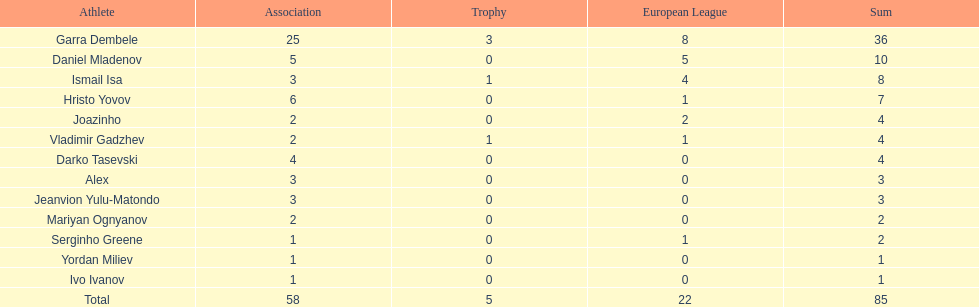Who was the top goalscorer on this team? Garra Dembele. 